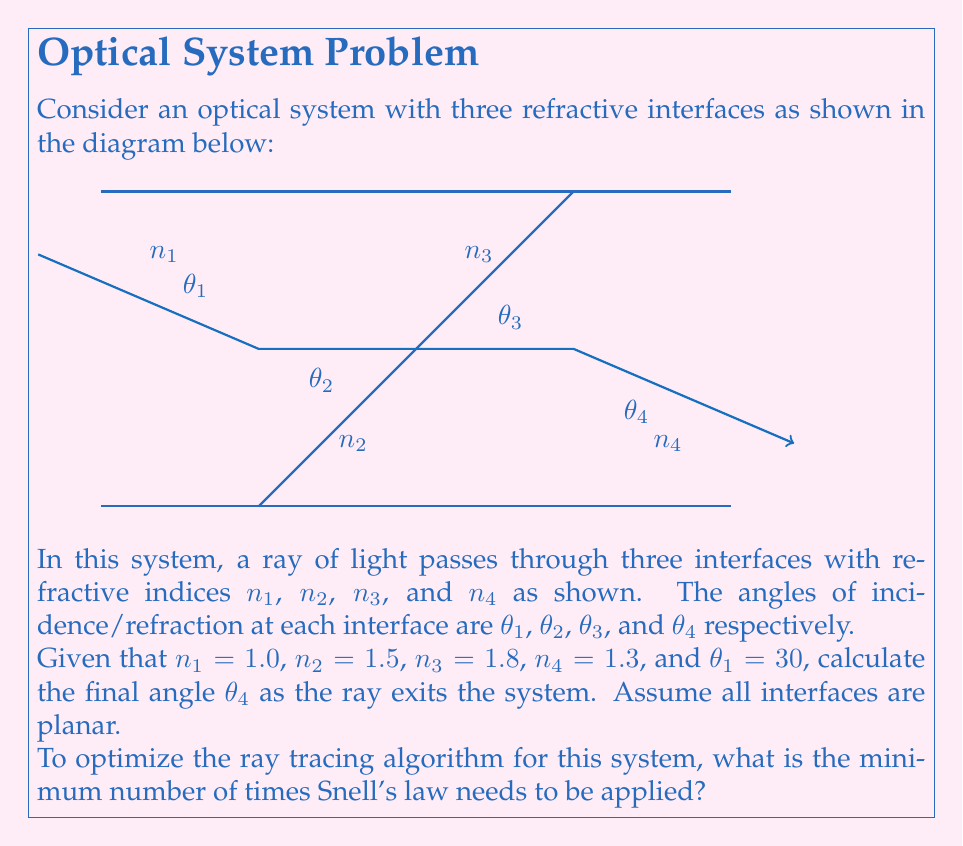What is the answer to this math problem? To solve this problem and optimize the ray tracing algorithm, we need to apply Snell's law at each interface. Let's go through the process step-by-step:

1) Snell's law states that $n_1 \sin(\theta_1) = n_2 \sin(\theta_2)$ for any two media.

2) At the first interface:
   $$n_1 \sin(\theta_1) = n_2 \sin(\theta_2)$$
   $$1.0 \sin(30°) = 1.5 \sin(\theta_2)$$
   $$\sin(\theta_2) = \frac{1.0 \sin(30°)}{1.5} = 0.3333$$
   $$\theta_2 = \arcsin(0.3333) = 19.47°$$

3) At the second interface:
   $$n_2 \sin(\theta_2) = n_3 \sin(\theta_3)$$
   $$1.5 \sin(19.47°) = 1.8 \sin(\theta_3)$$
   $$\sin(\theta_3) = \frac{1.5 \sin(19.47°)}{1.8} = 0.2778$$
   $$\theta_3 = \arcsin(0.2778) = 16.12°$$

4) At the third interface:
   $$n_3 \sin(\theta_3) = n_4 \sin(\theta_4)$$
   $$1.8 \sin(16.12°) = 1.3 \sin(\theta_4)$$
   $$\sin(\theta_4) = \frac{1.8 \sin(16.12°)}{1.3} = 0.3846$$
   $$\theta_4 = \arcsin(0.3846) = 22.62°$$

Therefore, the final angle $\theta_4$ as the ray exits the system is approximately 22.62°.

To optimize the ray tracing algorithm for this system, we need to apply Snell's law at each interface where the refractive index changes. In this case, there are three interfaces, so Snell's law needs to be applied three times.

This is the minimum number of times Snell's law needs to be applied because each interface represents a change in the medium, and thus a potential change in the ray's direction. Skipping any of these applications would result in an incorrect final angle.
Answer: 3 